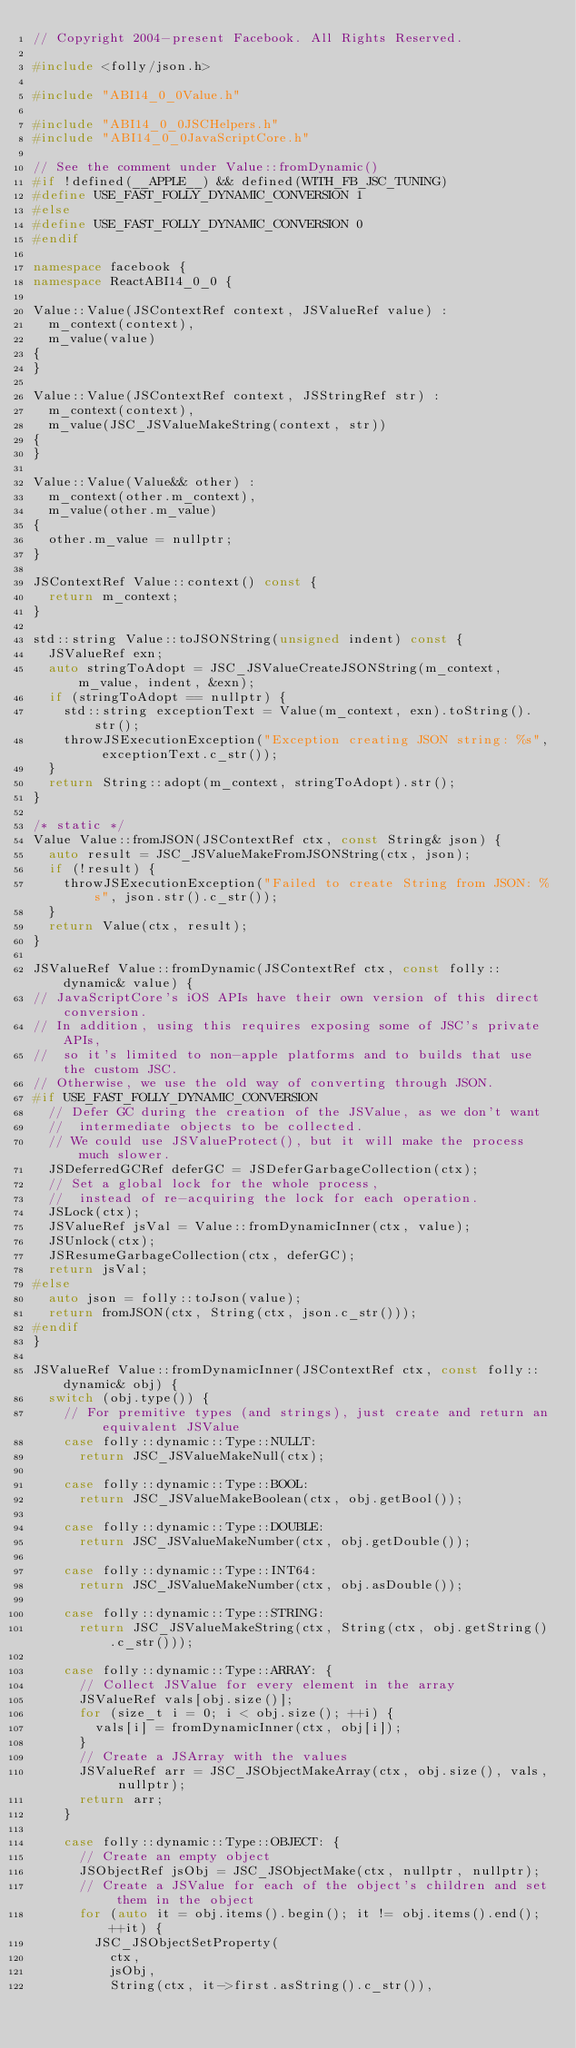Convert code to text. <code><loc_0><loc_0><loc_500><loc_500><_C++_>// Copyright 2004-present Facebook. All Rights Reserved.

#include <folly/json.h>

#include "ABI14_0_0Value.h"

#include "ABI14_0_0JSCHelpers.h"
#include "ABI14_0_0JavaScriptCore.h"

// See the comment under Value::fromDynamic()
#if !defined(__APPLE__) && defined(WITH_FB_JSC_TUNING)
#define USE_FAST_FOLLY_DYNAMIC_CONVERSION 1
#else
#define USE_FAST_FOLLY_DYNAMIC_CONVERSION 0
#endif

namespace facebook {
namespace ReactABI14_0_0 {

Value::Value(JSContextRef context, JSValueRef value) :
  m_context(context),
  m_value(value)
{
}

Value::Value(JSContextRef context, JSStringRef str) :
  m_context(context),
  m_value(JSC_JSValueMakeString(context, str))
{
}

Value::Value(Value&& other) :
  m_context(other.m_context),
  m_value(other.m_value)
{
  other.m_value = nullptr;
}

JSContextRef Value::context() const {
  return m_context;
}

std::string Value::toJSONString(unsigned indent) const {
  JSValueRef exn;
  auto stringToAdopt = JSC_JSValueCreateJSONString(m_context, m_value, indent, &exn);
  if (stringToAdopt == nullptr) {
    std::string exceptionText = Value(m_context, exn).toString().str();
    throwJSExecutionException("Exception creating JSON string: %s", exceptionText.c_str());
  }
  return String::adopt(m_context, stringToAdopt).str();
}

/* static */
Value Value::fromJSON(JSContextRef ctx, const String& json) {
  auto result = JSC_JSValueMakeFromJSONString(ctx, json);
  if (!result) {
    throwJSExecutionException("Failed to create String from JSON: %s", json.str().c_str());
  }
  return Value(ctx, result);
}

JSValueRef Value::fromDynamic(JSContextRef ctx, const folly::dynamic& value) {
// JavaScriptCore's iOS APIs have their own version of this direct conversion.
// In addition, using this requires exposing some of JSC's private APIs,
//  so it's limited to non-apple platforms and to builds that use the custom JSC.
// Otherwise, we use the old way of converting through JSON.
#if USE_FAST_FOLLY_DYNAMIC_CONVERSION
  // Defer GC during the creation of the JSValue, as we don't want
  //  intermediate objects to be collected.
  // We could use JSValueProtect(), but it will make the process much slower.
  JSDeferredGCRef deferGC = JSDeferGarbageCollection(ctx);
  // Set a global lock for the whole process,
  //  instead of re-acquiring the lock for each operation.
  JSLock(ctx);
  JSValueRef jsVal = Value::fromDynamicInner(ctx, value);
  JSUnlock(ctx);
  JSResumeGarbageCollection(ctx, deferGC);
  return jsVal;
#else
  auto json = folly::toJson(value);
  return fromJSON(ctx, String(ctx, json.c_str()));
#endif
}

JSValueRef Value::fromDynamicInner(JSContextRef ctx, const folly::dynamic& obj) {
  switch (obj.type()) {
    // For premitive types (and strings), just create and return an equivalent JSValue
    case folly::dynamic::Type::NULLT:
      return JSC_JSValueMakeNull(ctx);

    case folly::dynamic::Type::BOOL:
      return JSC_JSValueMakeBoolean(ctx, obj.getBool());

    case folly::dynamic::Type::DOUBLE:
      return JSC_JSValueMakeNumber(ctx, obj.getDouble());

    case folly::dynamic::Type::INT64:
      return JSC_JSValueMakeNumber(ctx, obj.asDouble());

    case folly::dynamic::Type::STRING:
      return JSC_JSValueMakeString(ctx, String(ctx, obj.getString().c_str()));

    case folly::dynamic::Type::ARRAY: {
      // Collect JSValue for every element in the array
      JSValueRef vals[obj.size()];
      for (size_t i = 0; i < obj.size(); ++i) {
        vals[i] = fromDynamicInner(ctx, obj[i]);
      }
      // Create a JSArray with the values
      JSValueRef arr = JSC_JSObjectMakeArray(ctx, obj.size(), vals, nullptr);
      return arr;
    }

    case folly::dynamic::Type::OBJECT: {
      // Create an empty object
      JSObjectRef jsObj = JSC_JSObjectMake(ctx, nullptr, nullptr);
      // Create a JSValue for each of the object's children and set them in the object
      for (auto it = obj.items().begin(); it != obj.items().end(); ++it) {
        JSC_JSObjectSetProperty(
          ctx,
          jsObj,
          String(ctx, it->first.asString().c_str()),</code> 